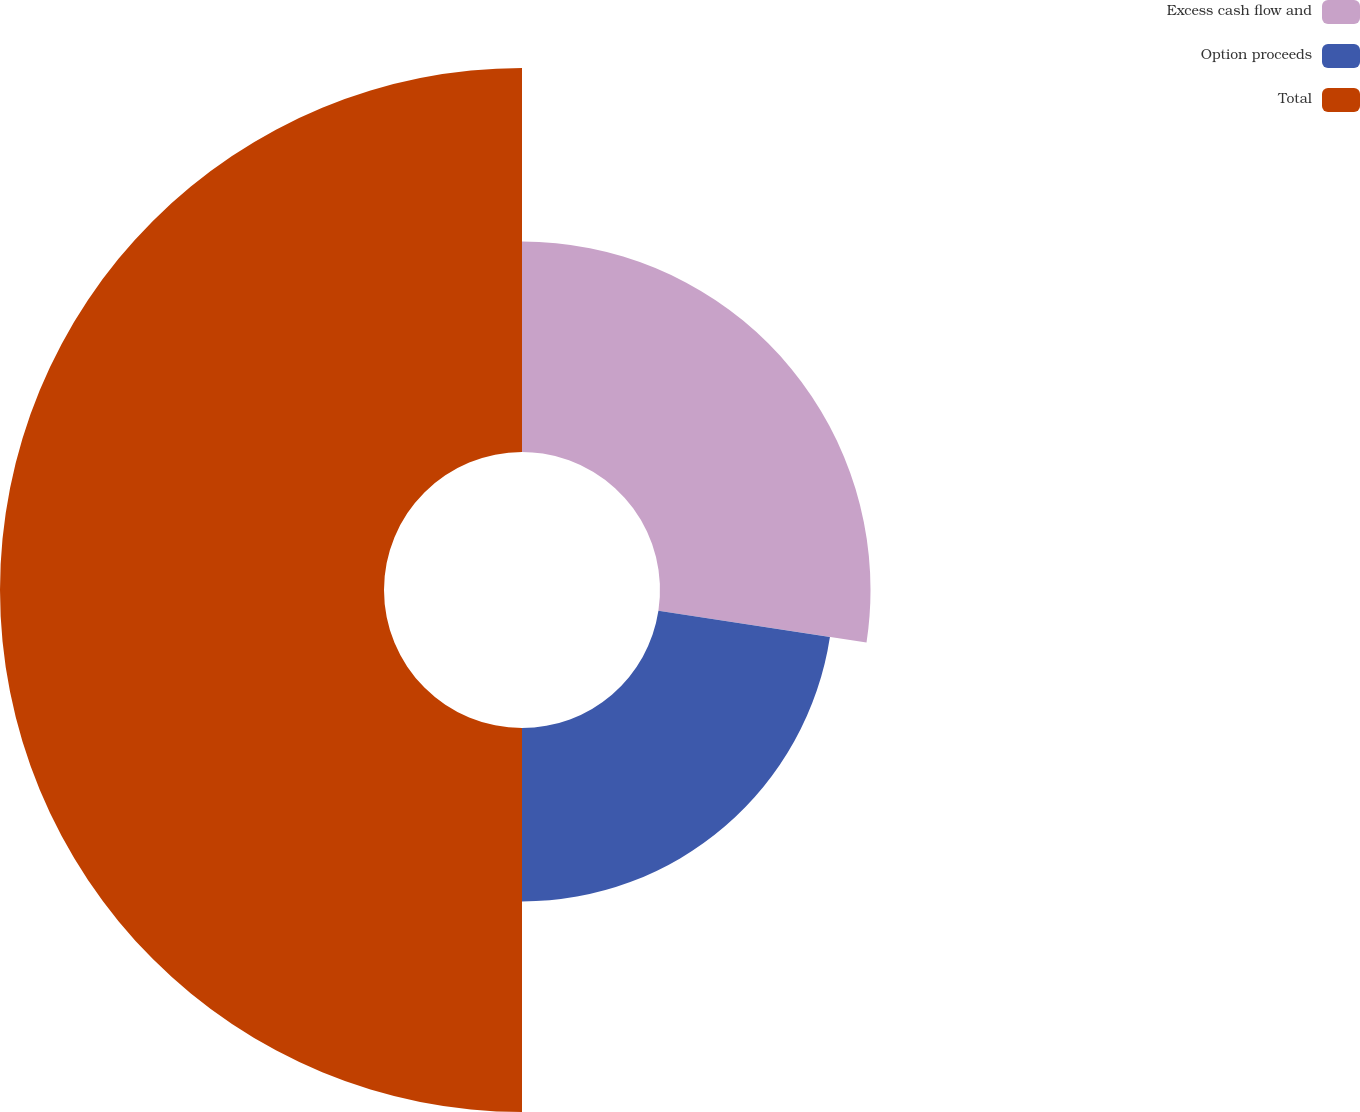Convert chart to OTSL. <chart><loc_0><loc_0><loc_500><loc_500><pie_chart><fcel>Excess cash flow and<fcel>Option proceeds<fcel>Total<nl><fcel>27.41%<fcel>22.59%<fcel>50.0%<nl></chart> 